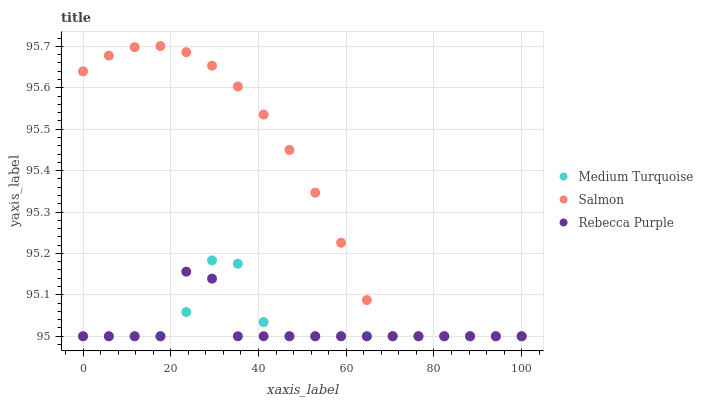Does Rebecca Purple have the minimum area under the curve?
Answer yes or no. Yes. Does Salmon have the maximum area under the curve?
Answer yes or no. Yes. Does Medium Turquoise have the minimum area under the curve?
Answer yes or no. No. Does Medium Turquoise have the maximum area under the curve?
Answer yes or no. No. Is Salmon the smoothest?
Answer yes or no. Yes. Is Rebecca Purple the roughest?
Answer yes or no. Yes. Is Medium Turquoise the smoothest?
Answer yes or no. No. Is Medium Turquoise the roughest?
Answer yes or no. No. Does Salmon have the lowest value?
Answer yes or no. Yes. Does Salmon have the highest value?
Answer yes or no. Yes. Does Medium Turquoise have the highest value?
Answer yes or no. No. Does Medium Turquoise intersect Rebecca Purple?
Answer yes or no. Yes. Is Medium Turquoise less than Rebecca Purple?
Answer yes or no. No. Is Medium Turquoise greater than Rebecca Purple?
Answer yes or no. No. 